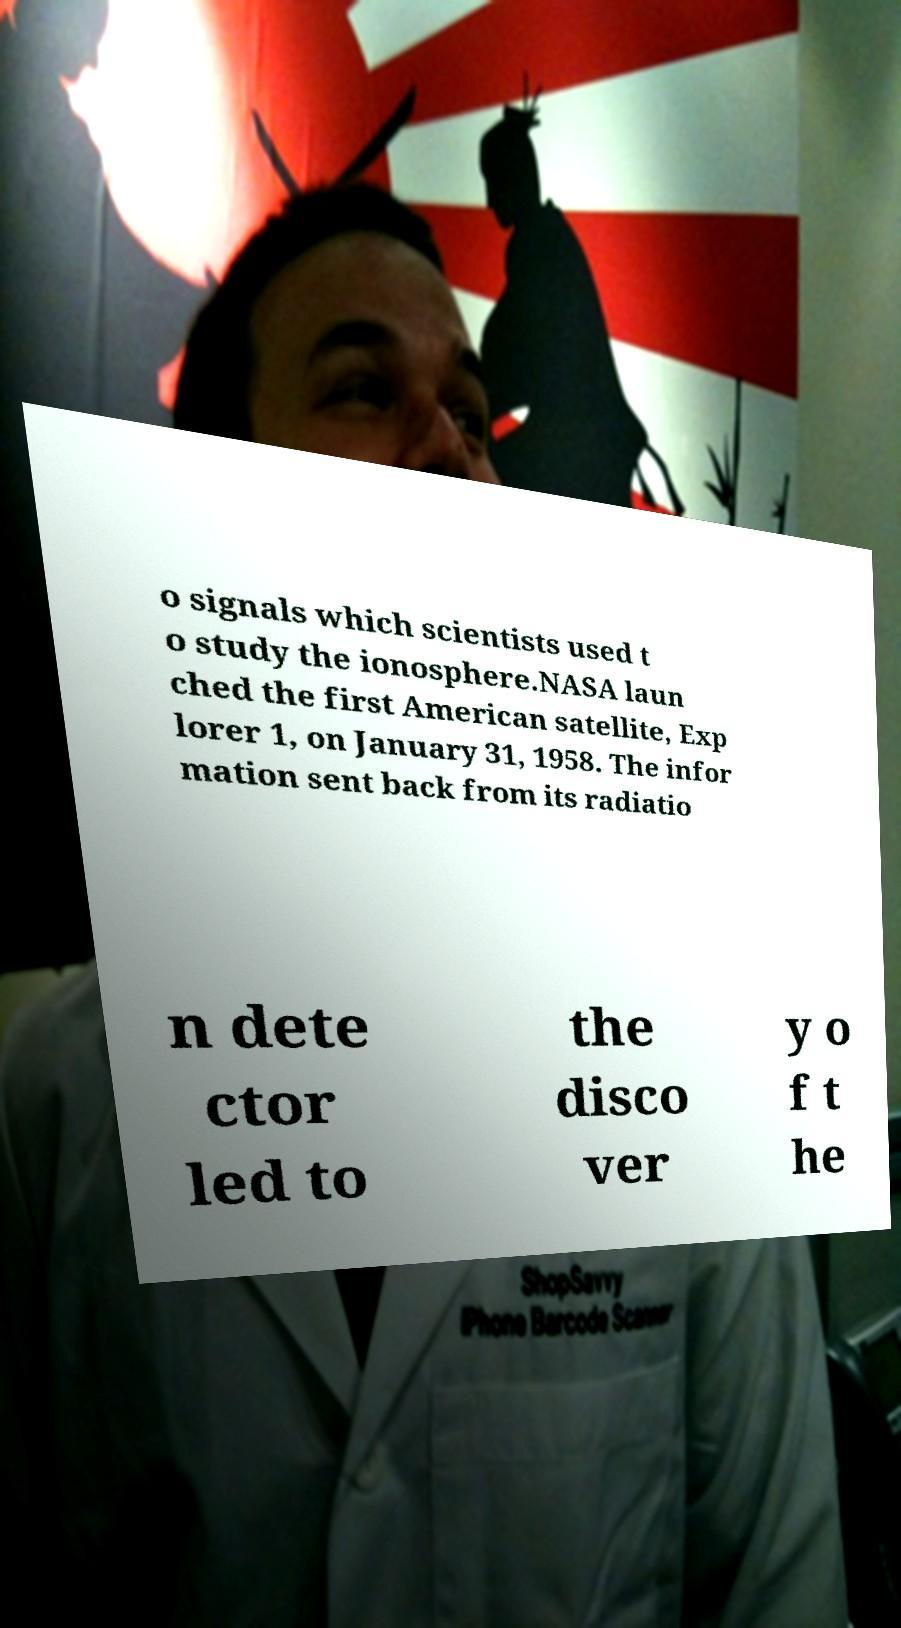Can you read and provide the text displayed in the image?This photo seems to have some interesting text. Can you extract and type it out for me? o signals which scientists used t o study the ionosphere.NASA laun ched the first American satellite, Exp lorer 1, on January 31, 1958. The infor mation sent back from its radiatio n dete ctor led to the disco ver y o f t he 